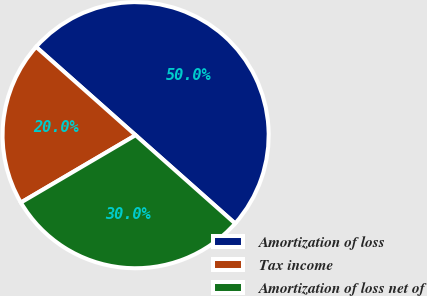Convert chart. <chart><loc_0><loc_0><loc_500><loc_500><pie_chart><fcel>Amortization of loss<fcel>Tax income<fcel>Amortization of loss net of<nl><fcel>50.0%<fcel>20.0%<fcel>30.0%<nl></chart> 